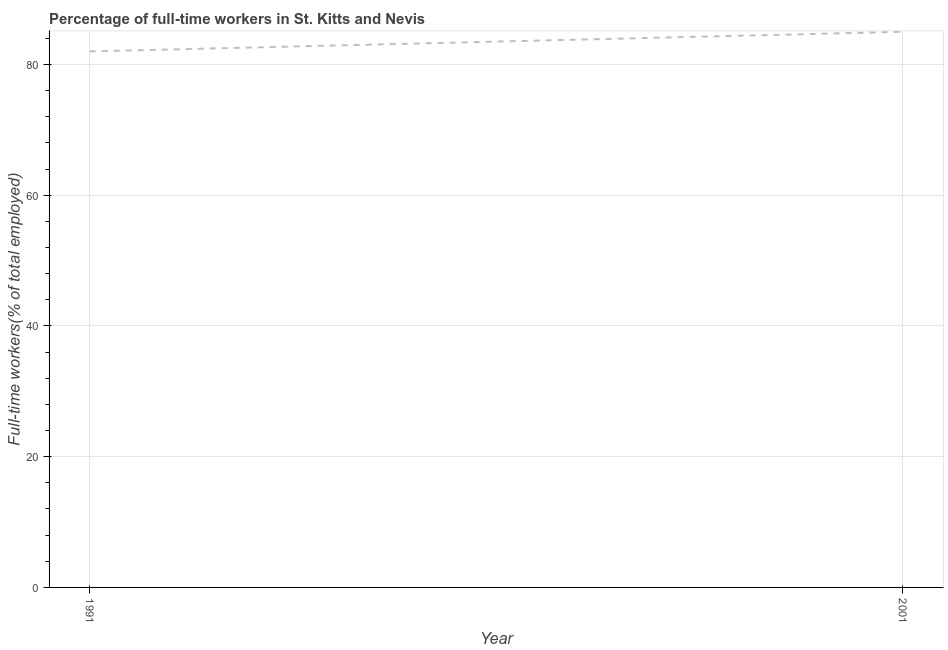What is the percentage of full-time workers in 1991?
Your answer should be very brief. 82. Across all years, what is the maximum percentage of full-time workers?
Your response must be concise. 85. Across all years, what is the minimum percentage of full-time workers?
Your answer should be very brief. 82. In which year was the percentage of full-time workers maximum?
Provide a succinct answer. 2001. In which year was the percentage of full-time workers minimum?
Provide a succinct answer. 1991. What is the sum of the percentage of full-time workers?
Your response must be concise. 167. What is the difference between the percentage of full-time workers in 1991 and 2001?
Offer a very short reply. -3. What is the average percentage of full-time workers per year?
Your answer should be compact. 83.5. What is the median percentage of full-time workers?
Ensure brevity in your answer.  83.5. In how many years, is the percentage of full-time workers greater than 20 %?
Make the answer very short. 2. Do a majority of the years between 2001 and 1991 (inclusive) have percentage of full-time workers greater than 76 %?
Your answer should be compact. No. What is the ratio of the percentage of full-time workers in 1991 to that in 2001?
Your response must be concise. 0.96. Is the percentage of full-time workers in 1991 less than that in 2001?
Keep it short and to the point. Yes. Does the percentage of full-time workers monotonically increase over the years?
Your answer should be very brief. Yes. What is the difference between two consecutive major ticks on the Y-axis?
Your answer should be compact. 20. Does the graph contain any zero values?
Provide a succinct answer. No. Does the graph contain grids?
Offer a terse response. Yes. What is the title of the graph?
Provide a succinct answer. Percentage of full-time workers in St. Kitts and Nevis. What is the label or title of the X-axis?
Provide a succinct answer. Year. What is the label or title of the Y-axis?
Your response must be concise. Full-time workers(% of total employed). What is the Full-time workers(% of total employed) of 1991?
Keep it short and to the point. 82. What is the Full-time workers(% of total employed) in 2001?
Give a very brief answer. 85. What is the difference between the Full-time workers(% of total employed) in 1991 and 2001?
Offer a terse response. -3. What is the ratio of the Full-time workers(% of total employed) in 1991 to that in 2001?
Provide a succinct answer. 0.96. 